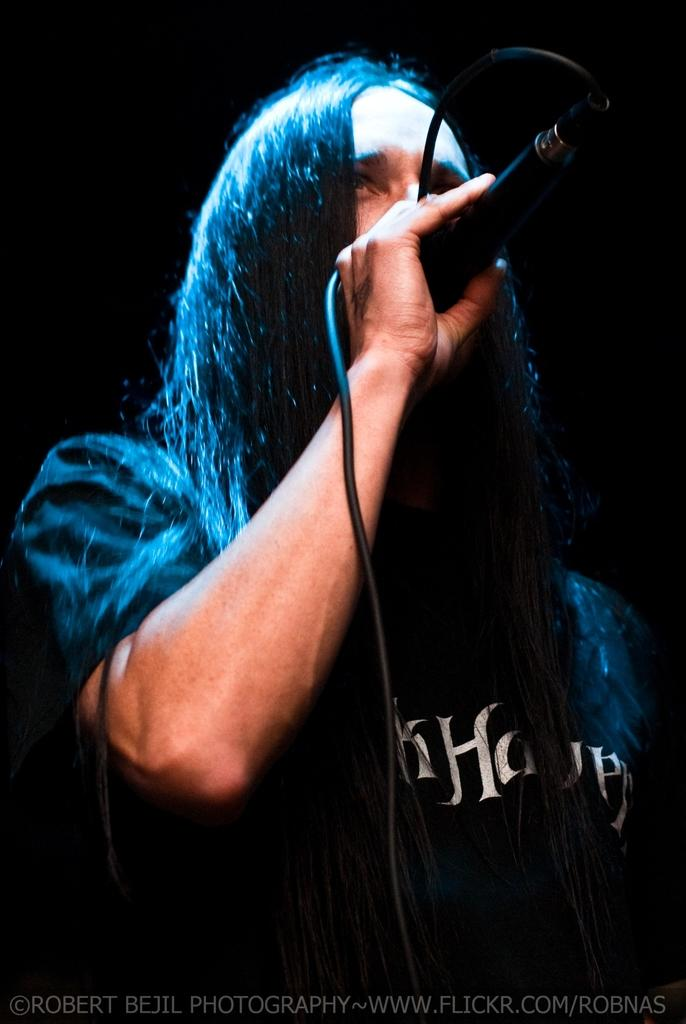What is the main subject in the foreground of the image? There is a man in the foreground of the image. What is the man wearing? The man is wearing a black T-shirt. What is the man holding in his hand? The man is holding a mic. How would you describe the background of the image? The background of the image is dark. What type of rice is being served at the feast in the image? There is no feast or rice present in the image; it features a man holding a mic in the foreground. What is the size of the man's nose in the image? The size of the man's nose cannot be determined from the image, as it is not mentioned in the provided facts. 